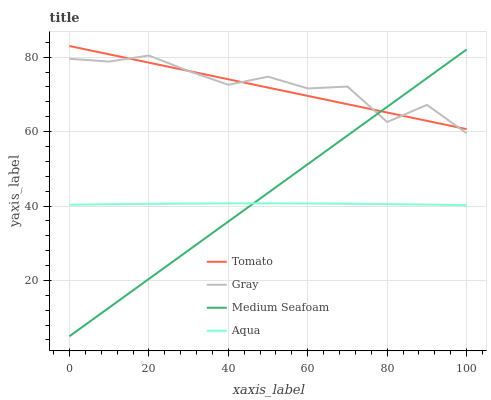Does Gray have the minimum area under the curve?
Answer yes or no. No. Does Aqua have the maximum area under the curve?
Answer yes or no. No. Is Aqua the smoothest?
Answer yes or no. No. Is Aqua the roughest?
Answer yes or no. No. Does Gray have the lowest value?
Answer yes or no. No. Does Gray have the highest value?
Answer yes or no. No. Is Aqua less than Gray?
Answer yes or no. Yes. Is Tomato greater than Aqua?
Answer yes or no. Yes. Does Aqua intersect Gray?
Answer yes or no. No. 